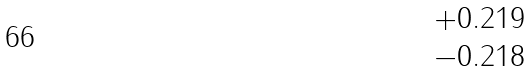<formula> <loc_0><loc_0><loc_500><loc_500>\begin{matrix} + 0 . 2 1 9 \\ - 0 . 2 1 8 \end{matrix}</formula> 